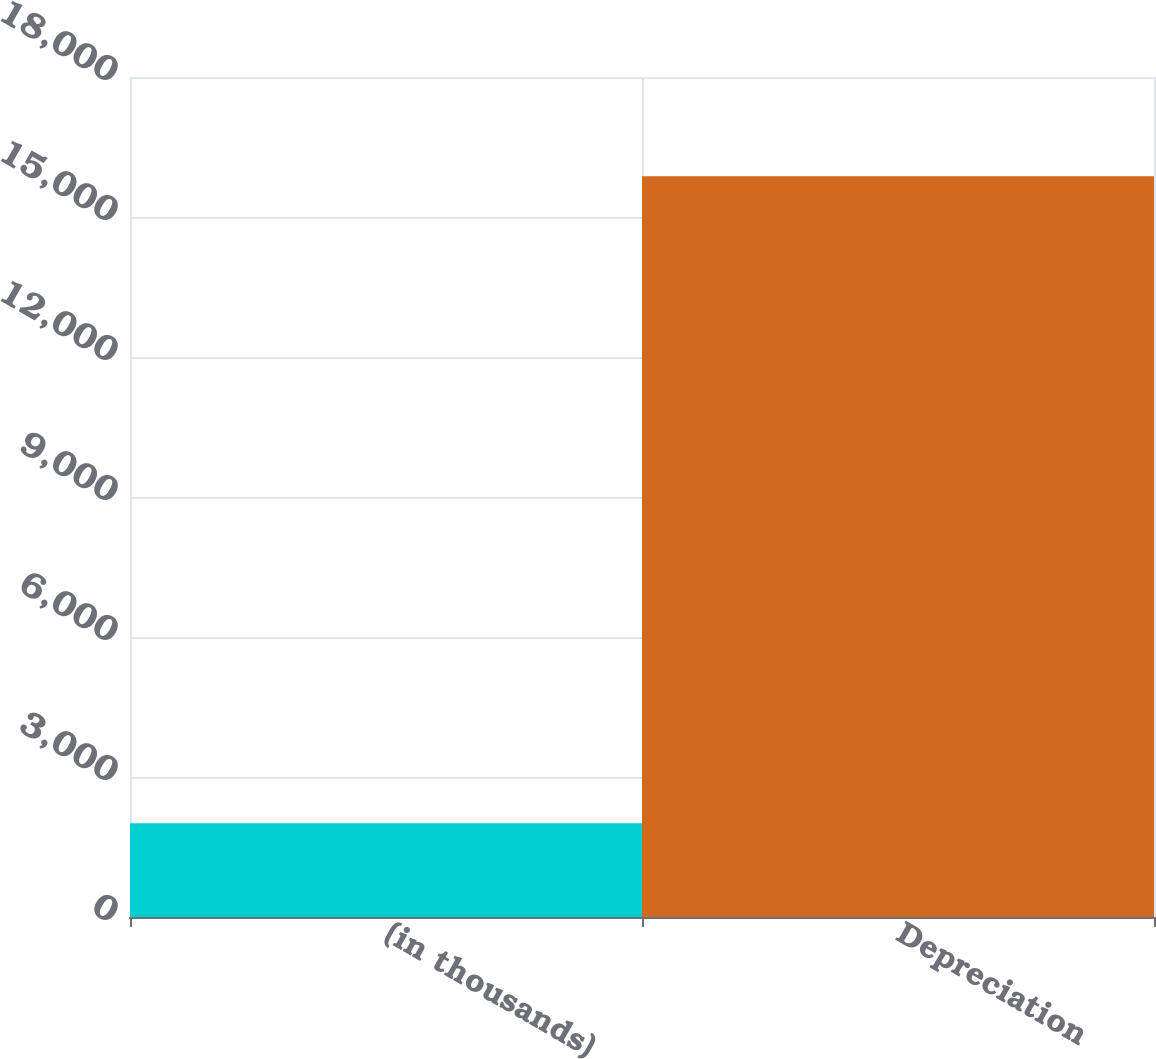Convert chart. <chart><loc_0><loc_0><loc_500><loc_500><bar_chart><fcel>(in thousands)<fcel>Depreciation<nl><fcel>2009<fcel>15874<nl></chart> 